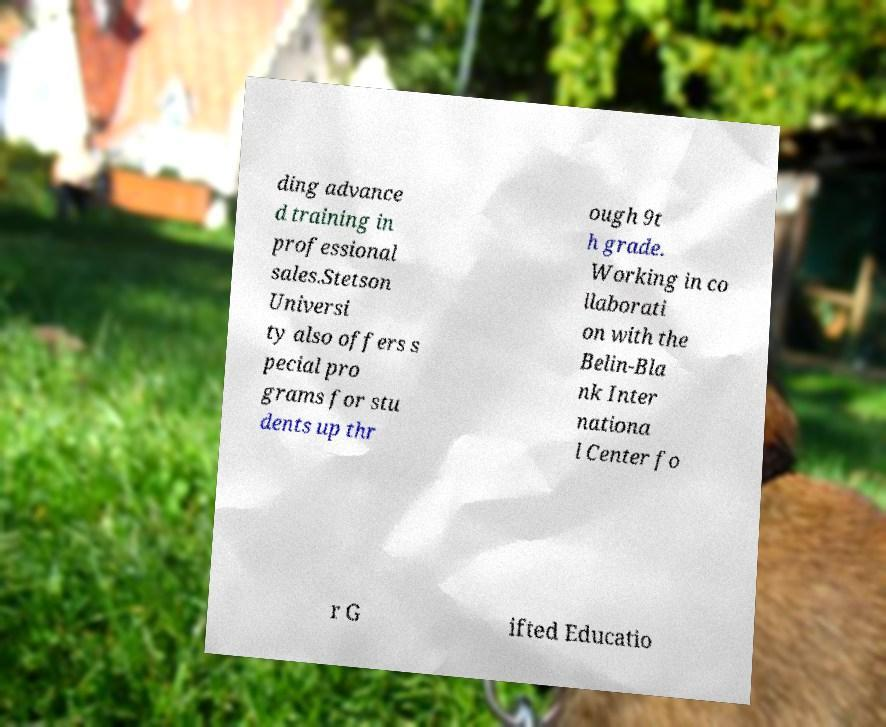Please read and relay the text visible in this image. What does it say? ding advance d training in professional sales.Stetson Universi ty also offers s pecial pro grams for stu dents up thr ough 9t h grade. Working in co llaborati on with the Belin-Bla nk Inter nationa l Center fo r G ifted Educatio 